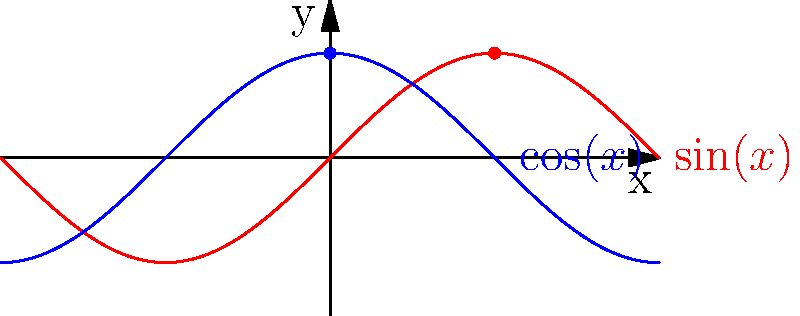In the context of business cycle theory, consider the phase space representation shown above. The red curve represents $\sin(x)$ and the blue curve represents $\cos(x)$. How does this topological structure relate to the concept of economic cycles, and what significant point does it illustrate about the nature of business fluctuations? To understand the relationship between this topological structure and business cycle theory, let's break it down step-by-step:

1. Periodic nature: Both $\sin(x)$ and $\cos(x)$ are periodic functions, repeating every $2\pi$. This periodicity is analogous to the cyclical nature of economic expansions and contractions in business cycles.

2. Phase shift: The $\cos(x)$ function is a phase-shifted version of $\sin(x)$, specifically by $\frac{\pi}{2}$. In economic terms, this represents how different economic indicators may lead or lag each other in the business cycle.

3. Continuous and smooth: The curves are continuous and smooth, reflecting the idea that economic transitions are often gradual rather than abrupt.

4. Bounded oscillations: Both functions oscillate between -1 and 1, which can represent the upper and lower bounds of economic activity in a normalized scale.

5. Interrelated variables: The relationship between $\sin(x)$ and $\cos(x)$ (i.e., $\frac{d}{dx}\sin(x) = \cos(x)$) mirrors how different economic variables are interrelated and influence each other's behavior over time.

6. Toroidal topology: If we consider this as a parametric plot $(x(t), y(t)) = (\cos(t), \sin(t))$, it forms a circle. In higher dimensions, this generalizes to a torus, which is a common topological structure in phase spaces of certain dynamical systems.

7. Limit cycles: The circular structure formed by these functions represents a limit cycle in dynamical systems theory. In economics, this could model self-sustaining oscillations in the economy.

The key point illustrated is that economic cycles can be viewed as deterministic, yet complex systems with inherent periodicities and interrelationships between variables, capable of sustained oscillations without external drivers.
Answer: Deterministic, periodic system with interrelated variables exhibiting sustained oscillations (limit cycle) 